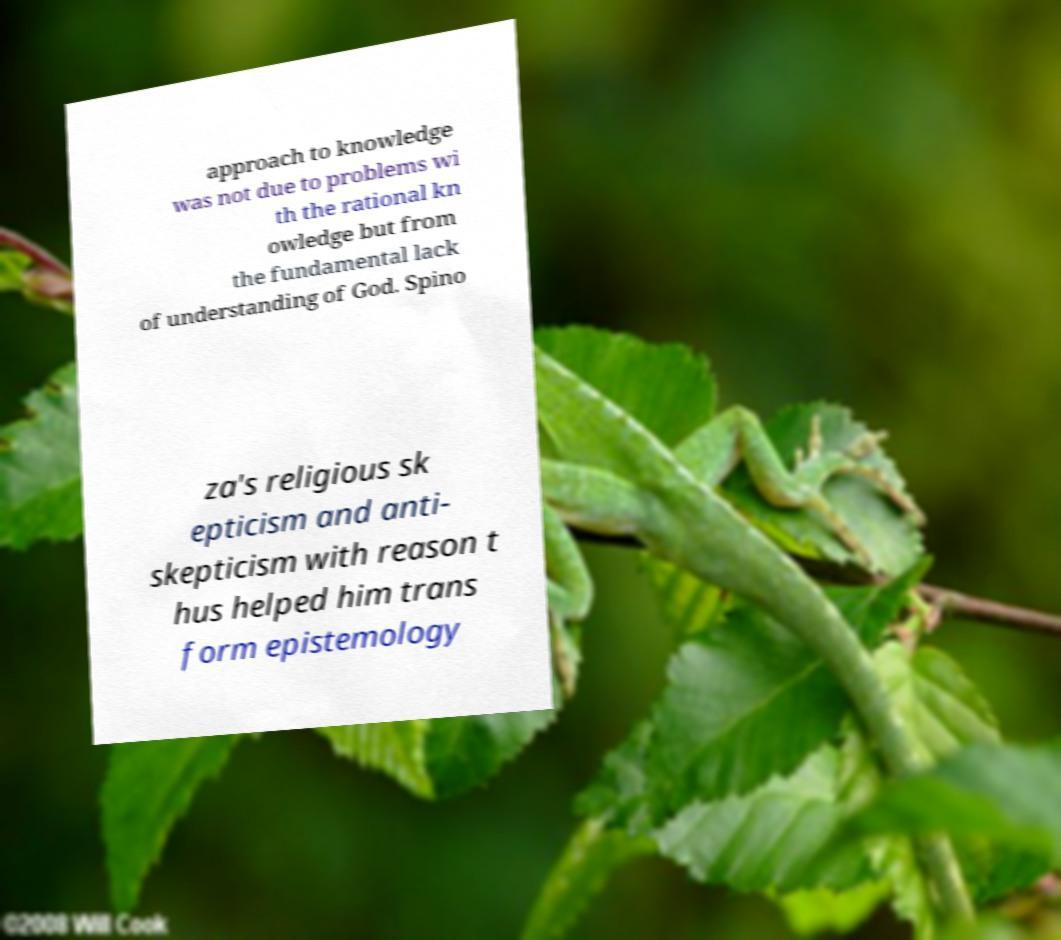What messages or text are displayed in this image? I need them in a readable, typed format. approach to knowledge was not due to problems wi th the rational kn owledge but from the fundamental lack of understanding of God. Spino za's religious sk epticism and anti- skepticism with reason t hus helped him trans form epistemology 